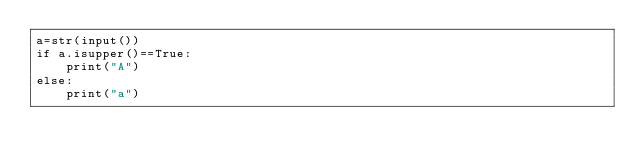<code> <loc_0><loc_0><loc_500><loc_500><_Python_>a=str(input())
if a.isupper()==True:
    print("A")
else:
    print("a")
</code> 